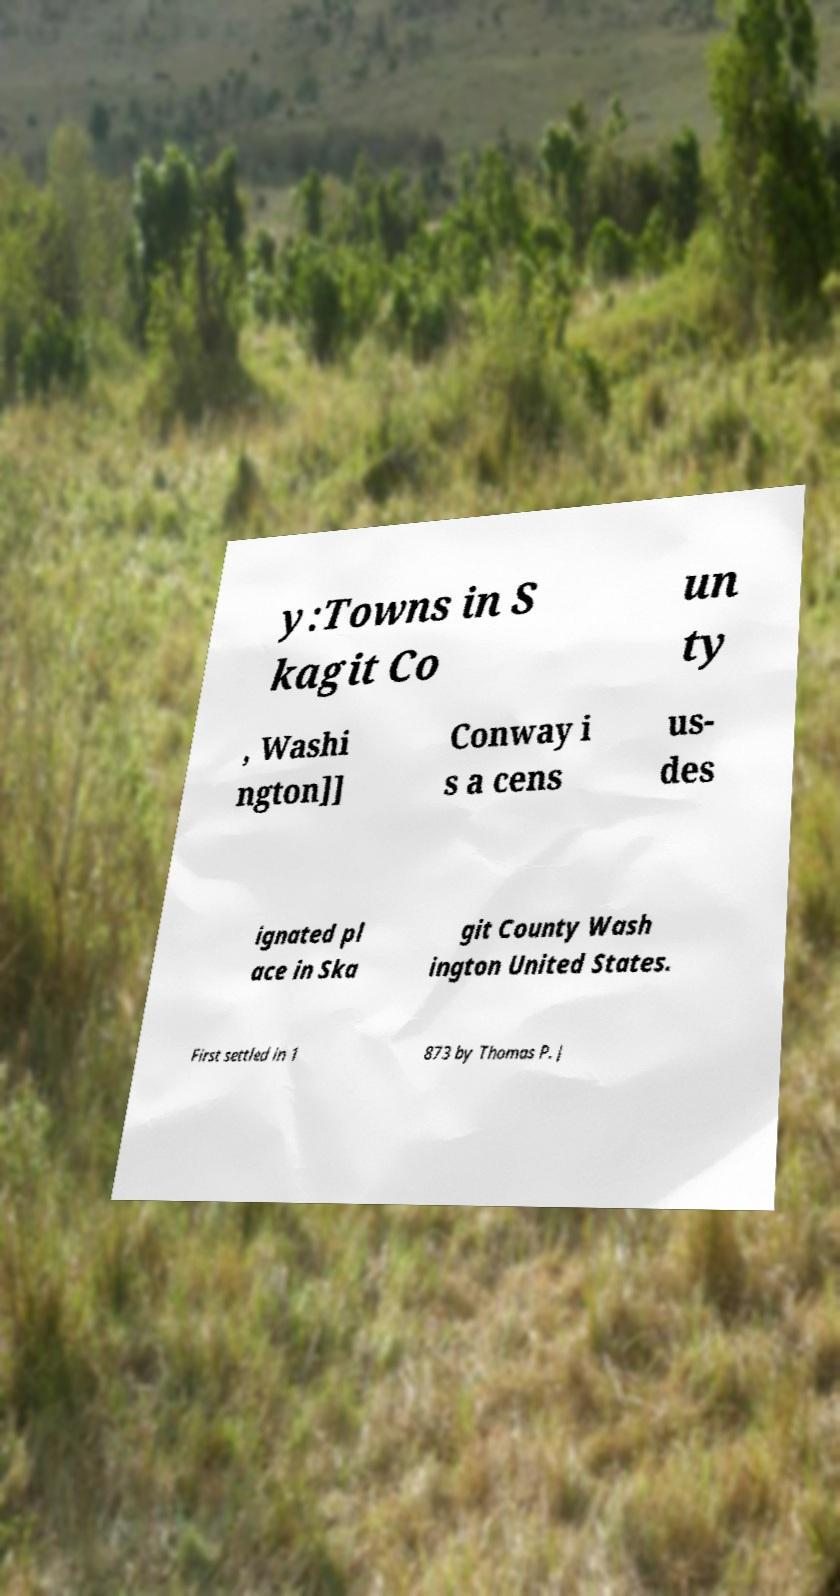Please read and relay the text visible in this image. What does it say? y:Towns in S kagit Co un ty , Washi ngton]] Conway i s a cens us- des ignated pl ace in Ska git County Wash ington United States. First settled in 1 873 by Thomas P. J 